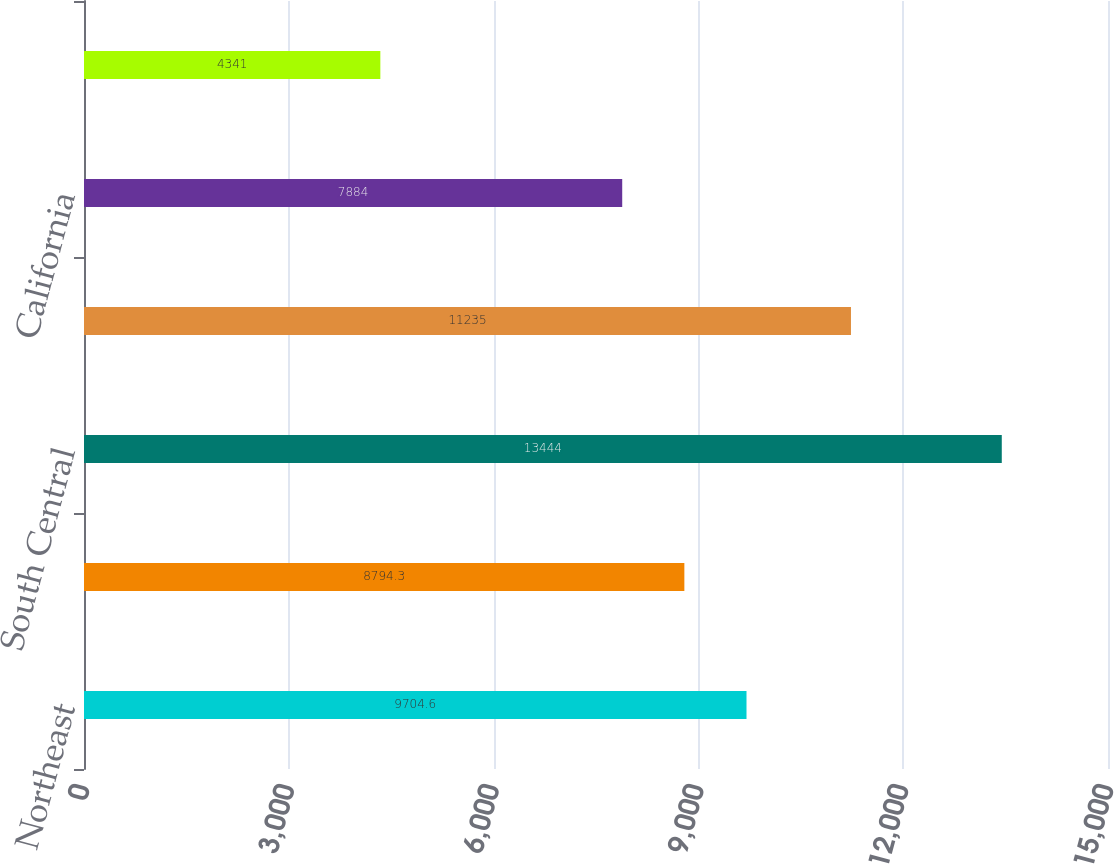Convert chart. <chart><loc_0><loc_0><loc_500><loc_500><bar_chart><fcel>Northeast<fcel>Southeast<fcel>South Central<fcel>Southwest<fcel>California<fcel>West<nl><fcel>9704.6<fcel>8794.3<fcel>13444<fcel>11235<fcel>7884<fcel>4341<nl></chart> 